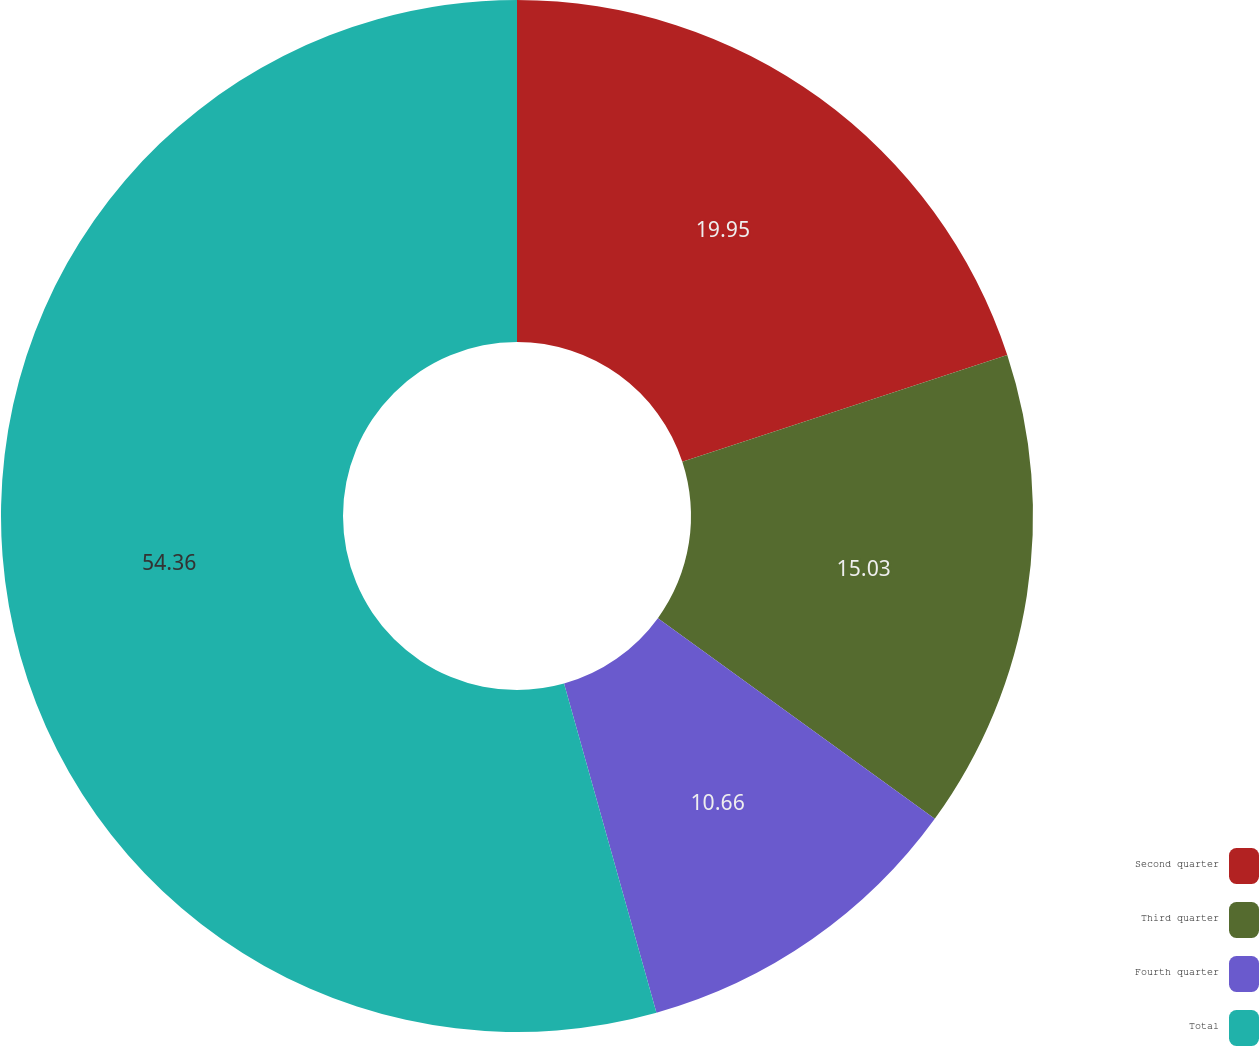Convert chart. <chart><loc_0><loc_0><loc_500><loc_500><pie_chart><fcel>Second quarter<fcel>Third quarter<fcel>Fourth quarter<fcel>Total<nl><fcel>19.95%<fcel>15.03%<fcel>10.66%<fcel>54.35%<nl></chart> 